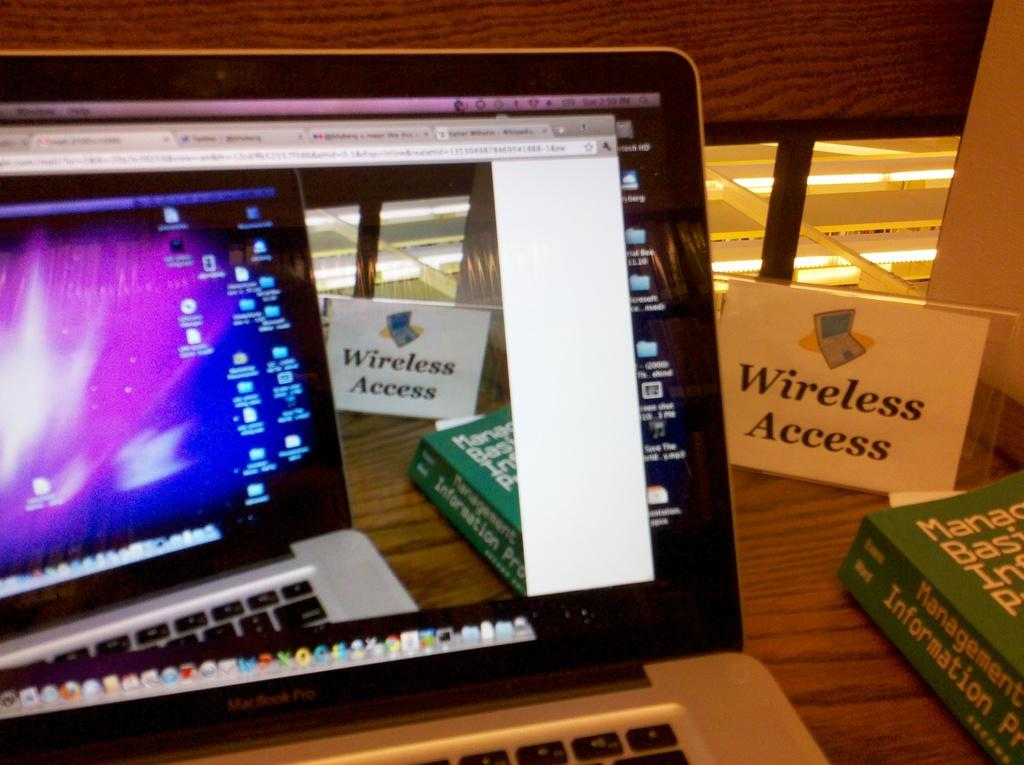<image>
Write a terse but informative summary of the picture. a macbook pro screen turned on with a paper next to it that says 'wireless access' 